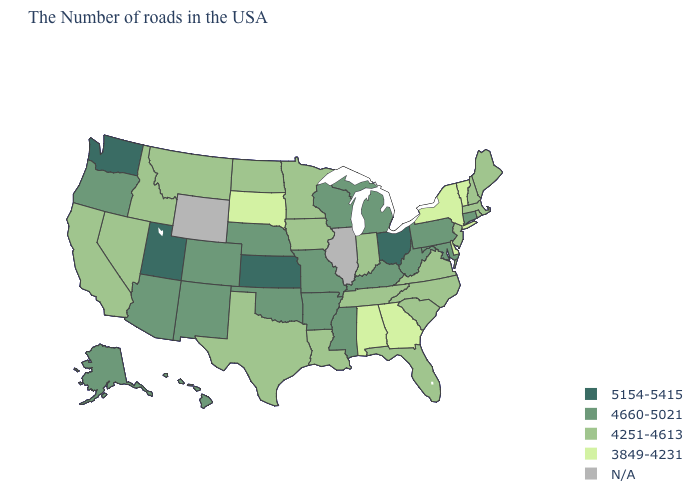Name the states that have a value in the range 5154-5415?
Concise answer only. Ohio, Kansas, Utah, Washington. What is the value of Alaska?
Answer briefly. 4660-5021. Which states have the highest value in the USA?
Keep it brief. Ohio, Kansas, Utah, Washington. How many symbols are there in the legend?
Write a very short answer. 5. What is the lowest value in states that border Maine?
Write a very short answer. 4251-4613. Name the states that have a value in the range 5154-5415?
Short answer required. Ohio, Kansas, Utah, Washington. What is the value of Michigan?
Give a very brief answer. 4660-5021. What is the value of Arkansas?
Short answer required. 4660-5021. How many symbols are there in the legend?
Quick response, please. 5. Name the states that have a value in the range 5154-5415?
Concise answer only. Ohio, Kansas, Utah, Washington. Which states have the lowest value in the MidWest?
Concise answer only. South Dakota. Is the legend a continuous bar?
Keep it brief. No. Among the states that border Indiana , does Ohio have the highest value?
Give a very brief answer. Yes. Name the states that have a value in the range N/A?
Short answer required. Illinois, Wyoming. What is the value of New Jersey?
Give a very brief answer. 4251-4613. 